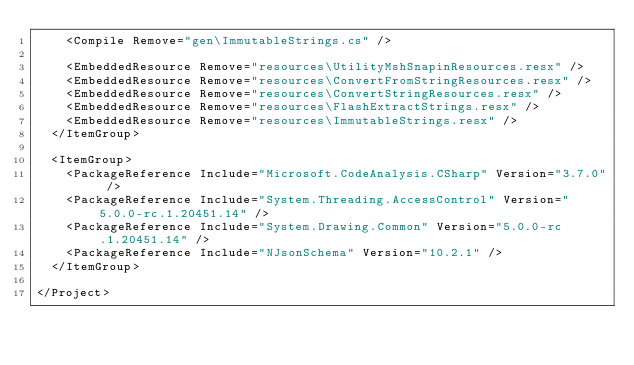Convert code to text. <code><loc_0><loc_0><loc_500><loc_500><_XML_>    <Compile Remove="gen\ImmutableStrings.cs" />

    <EmbeddedResource Remove="resources\UtilityMshSnapinResources.resx" />
    <EmbeddedResource Remove="resources\ConvertFromStringResources.resx" />
    <EmbeddedResource Remove="resources\ConvertStringResources.resx" />
    <EmbeddedResource Remove="resources\FlashExtractStrings.resx" />
    <EmbeddedResource Remove="resources\ImmutableStrings.resx" />
  </ItemGroup>

  <ItemGroup>
    <PackageReference Include="Microsoft.CodeAnalysis.CSharp" Version="3.7.0" />
    <PackageReference Include="System.Threading.AccessControl" Version="5.0.0-rc.1.20451.14" />
    <PackageReference Include="System.Drawing.Common" Version="5.0.0-rc.1.20451.14" />
    <PackageReference Include="NJsonSchema" Version="10.2.1" />
  </ItemGroup>

</Project>
</code> 